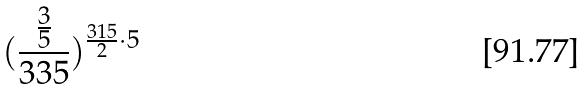<formula> <loc_0><loc_0><loc_500><loc_500>( \frac { \frac { 3 } { 5 } } { 3 3 5 } ) ^ { \frac { 3 1 5 } { 2 } \cdot 5 }</formula> 